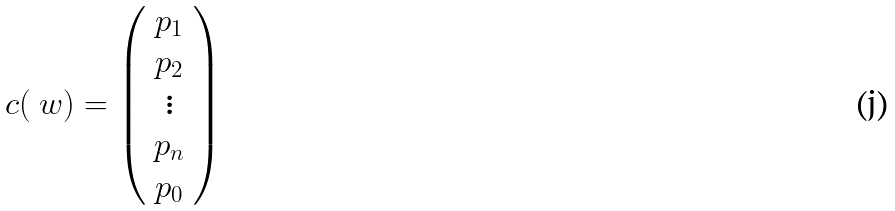<formula> <loc_0><loc_0><loc_500><loc_500>c ( \ w ) = \left ( \begin{array} { c } p _ { 1 } \\ p _ { 2 } \\ \vdots \\ p _ { n } \\ p _ { 0 } \\ \end{array} \right )</formula> 